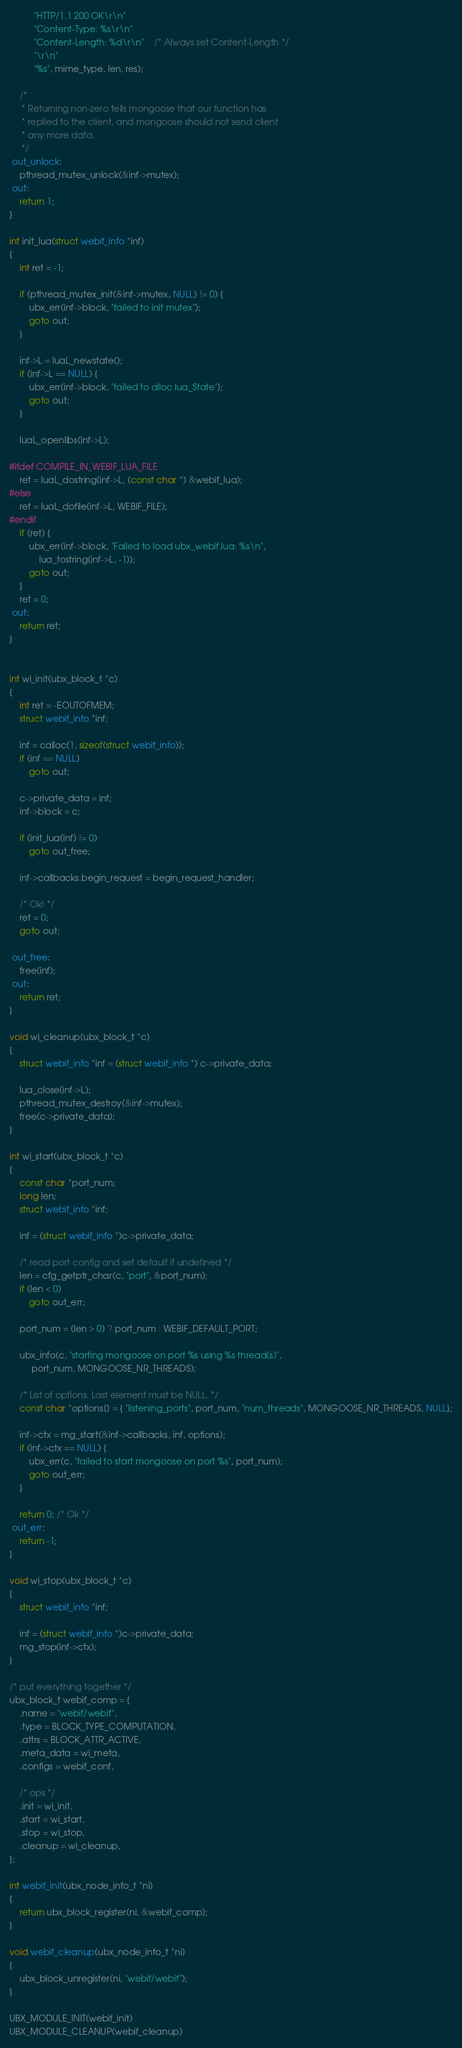Convert code to text. <code><loc_0><loc_0><loc_500><loc_500><_C_>		  "HTTP/1.1 200 OK\r\n"
		  "Content-Type: %s\r\n"
		  "Content-Length: %d\r\n"	/* Always set Content-Length */
		  "\r\n"
		  "%s", mime_type, len, res);

	/*
	 * Returning non-zero tells mongoose that our function has
	 * replied to the client, and mongoose should not send client
	 * any more data.
	 */
 out_unlock:
	pthread_mutex_unlock(&inf->mutex);
 out:
	return 1;
}

int init_lua(struct webif_info *inf)
{
	int ret = -1;

	if (pthread_mutex_init(&inf->mutex, NULL) != 0) {
		ubx_err(inf->block, "failed to init mutex");
		goto out;
	}

	inf->L = luaL_newstate();
	if (inf->L == NULL) {
		ubx_err(inf->block, "failed to alloc lua_State");
		goto out;
	}

	luaL_openlibs(inf->L);

#ifdef COMPILE_IN_WEBIF_LUA_FILE
	ret = luaL_dostring(inf->L, (const char *) &webif_lua);
#else
	ret = luaL_dofile(inf->L, WEBIF_FILE);
#endif
	if (ret) {
		ubx_err(inf->block, "Failed to load ubx_webif.lua: %s\n",
			lua_tostring(inf->L, -1));
		goto out;
	}
	ret = 0;
 out:
	return ret;
}


int wi_init(ubx_block_t *c)
{
	int ret = -EOUTOFMEM;
	struct webif_info *inf;

	inf = calloc(1, sizeof(struct webif_info));
	if (inf == NULL)
		goto out;

	c->private_data = inf;
	inf->block = c;

	if (init_lua(inf) != 0)
		goto out_free;

	inf->callbacks.begin_request = begin_request_handler;

	/* Ok! */
	ret = 0;
	goto out;

 out_free:
	free(inf);
 out:
	return ret;
}

void wi_cleanup(ubx_block_t *c)
{
	struct webif_info *inf = (struct webif_info *) c->private_data;

	lua_close(inf->L);
	pthread_mutex_destroy(&inf->mutex);
	free(c->private_data);
}

int wi_start(ubx_block_t *c)
{
	const char *port_num;
	long len;
	struct webif_info *inf;

	inf = (struct webif_info *)c->private_data;

	/* read port config and set default if undefined */
	len = cfg_getptr_char(c, "port", &port_num);
	if (len < 0)
		goto out_err;

	port_num = (len > 0) ? port_num : WEBIF_DEFAULT_PORT;

	ubx_info(c, "starting mongoose on port %s using %s thread(s)",
		 port_num, MONGOOSE_NR_THREADS);

	/* List of options. Last element must be NULL. */
	const char *options[] = { "listening_ports", port_num, "num_threads", MONGOOSE_NR_THREADS, NULL};

	inf->ctx = mg_start(&inf->callbacks, inf, options);
	if (inf->ctx == NULL) {
		ubx_err(c, "failed to start mongoose on port %s", port_num);
		goto out_err;
	}

	return 0; /* Ok */
 out_err:
	return -1;
}

void wi_stop(ubx_block_t *c)
{
	struct webif_info *inf;

	inf = (struct webif_info *)c->private_data;
	mg_stop(inf->ctx);
}

/* put everything together */
ubx_block_t webif_comp = {
	.name = "webif/webif",
	.type = BLOCK_TYPE_COMPUTATION,
	.attrs = BLOCK_ATTR_ACTIVE,
	.meta_data = wi_meta,
	.configs = webif_conf,

	/* ops */
	.init = wi_init,
	.start = wi_start,
	.stop = wi_stop,
	.cleanup = wi_cleanup,
};

int webif_init(ubx_node_info_t *ni)
{
	return ubx_block_register(ni, &webif_comp);
}

void webif_cleanup(ubx_node_info_t *ni)
{
	ubx_block_unregister(ni, "webif/webif");
}

UBX_MODULE_INIT(webif_init)
UBX_MODULE_CLEANUP(webif_cleanup)
</code> 